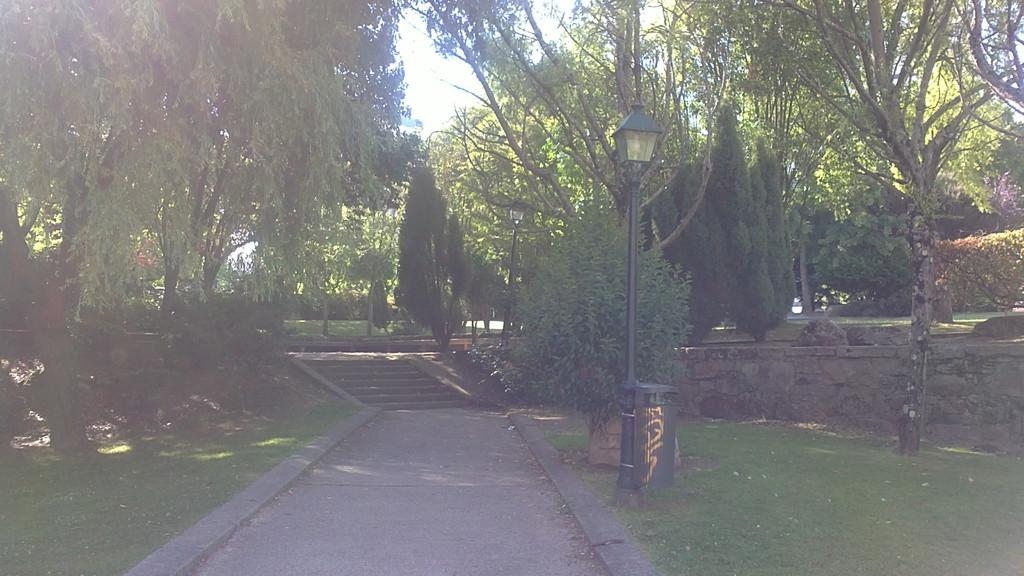What is located on the ground in the image? There is an object on the ground in the image. What architectural feature can be seen in the image? There are stairs in the image. What type of vegetation is present in the image? Grass and plants are visible in the image. What type of natural elements can be seen in the image? Rocks are visible in the image. What man-made structures are present in the image? Poles and a wall are visible in the image. What part of the natural environment is visible in the image? The sky is visible in the image. What type of beetle can be seen crawling on the wall in the image? There is no beetle present in the image; only the object, stairs, grass, plants, rocks, poles, wall, and sky are visible. What year is depicted in the image? The image does not depict a specific year; it is a static representation of the scene. 